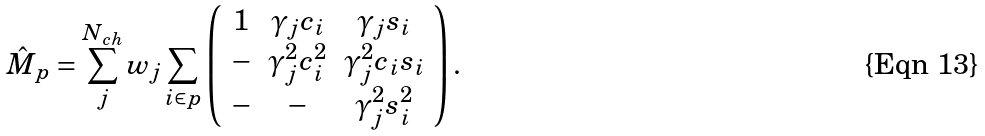Convert formula to latex. <formula><loc_0><loc_0><loc_500><loc_500>\hat { M } _ { p } = \sum _ { j } ^ { N _ { c h } } w _ { j } \sum _ { i \in p } \left ( \begin{array} { c c c } 1 & \gamma _ { j } c _ { i } & \gamma _ { j } s _ { i } \\ - & \gamma _ { j } ^ { 2 } c _ { i } ^ { 2 } & \gamma _ { j } ^ { 2 } c _ { i } s _ { i } \\ - & - & \gamma _ { j } ^ { 2 } s _ { i } ^ { 2 } \\ \end{array} \right ) .</formula> 